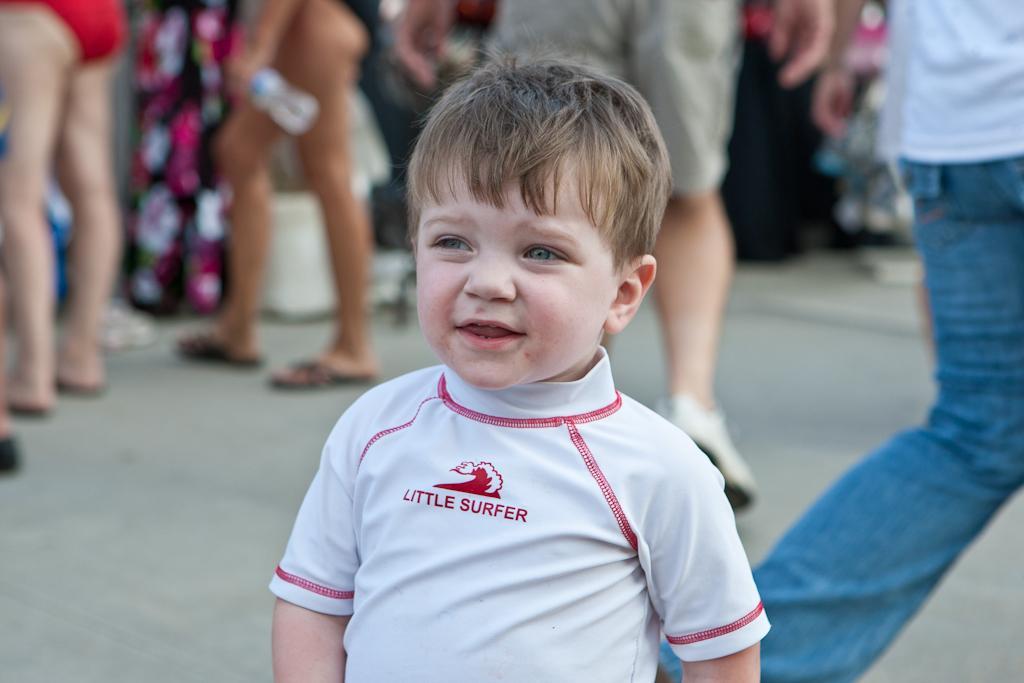Could you give a brief overview of what you see in this image? In the picture we can see a small boy standing on the path with white T-shirt and behind him we can see some people's legs standing and some are walking. 